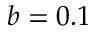<formula> <loc_0><loc_0><loc_500><loc_500>b = 0 . 1</formula> 